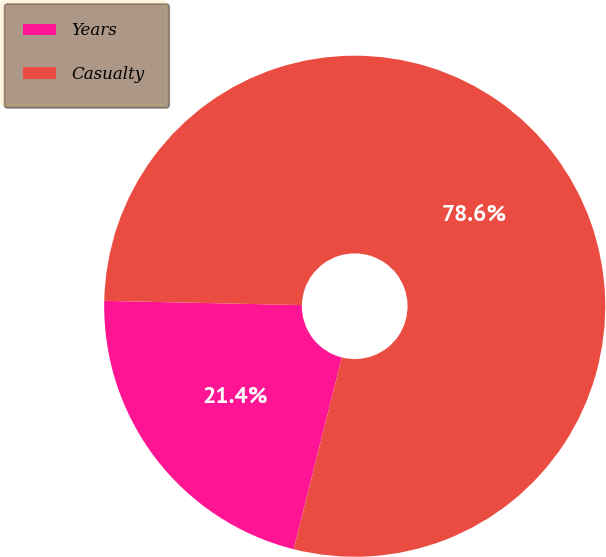Convert chart. <chart><loc_0><loc_0><loc_500><loc_500><pie_chart><fcel>Years<fcel>Casualty<nl><fcel>21.43%<fcel>78.57%<nl></chart> 